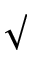Convert formula to latex. <formula><loc_0><loc_0><loc_500><loc_500>\surd</formula> 